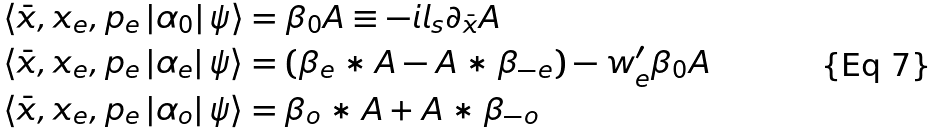<formula> <loc_0><loc_0><loc_500><loc_500>& \langle \bar { x } , x _ { e } , p _ { e } \left | \alpha _ { 0 } \right | \psi \rangle = \beta _ { 0 } A \equiv - i l _ { s } \partial _ { \bar { x } } A \\ & \langle \bar { x } , x _ { e } , p _ { e } \left | \alpha _ { e } \right | \psi \rangle = \left ( \beta _ { e } \ast A - A \ast \beta _ { - e } \right ) - w _ { e } ^ { \prime } \beta _ { 0 } A \\ & \langle \bar { x } , x _ { e } , p _ { e } \left | \alpha _ { o } \right | \psi \rangle = \beta _ { o } \ast A + A \ast \beta _ { - o }</formula> 